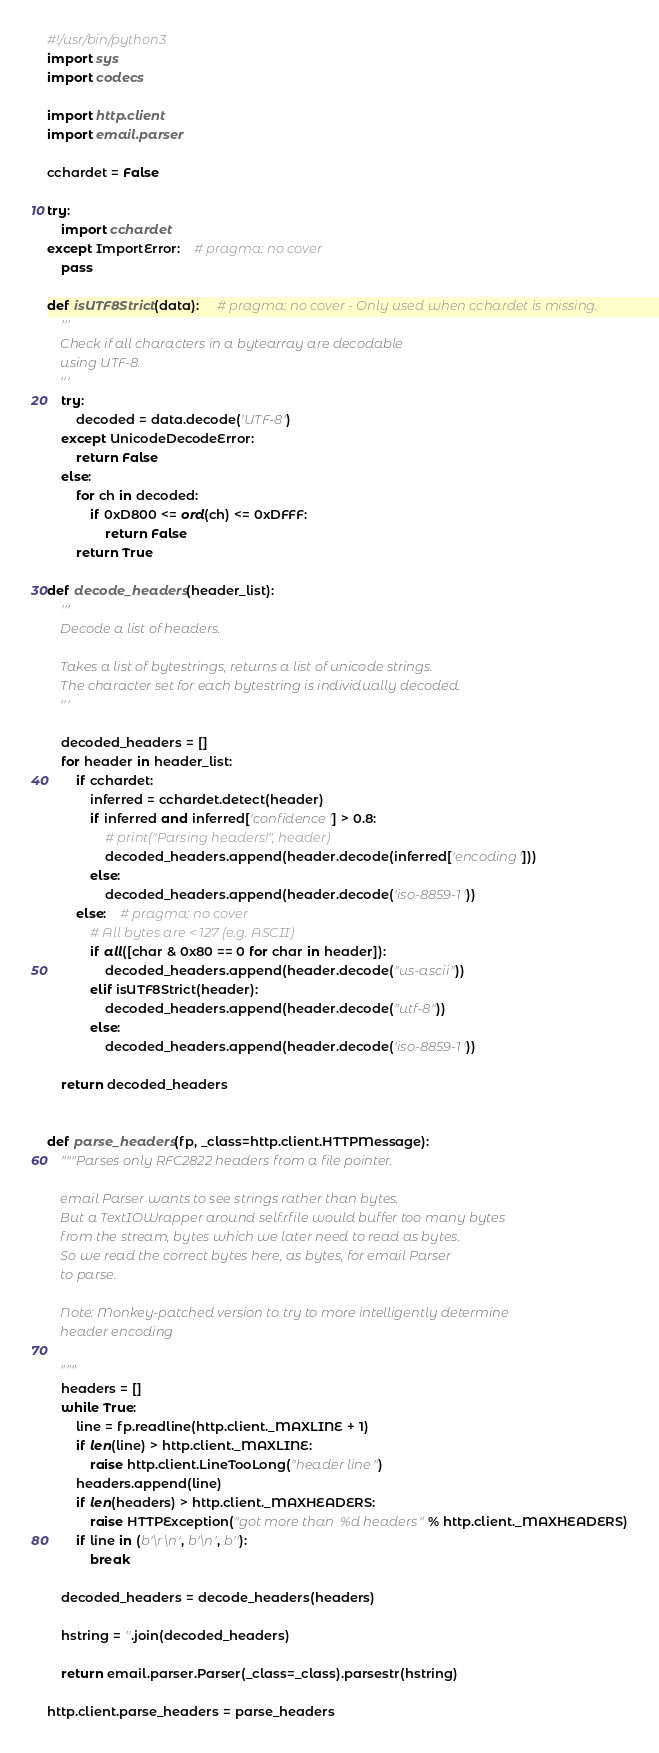Convert code to text. <code><loc_0><loc_0><loc_500><loc_500><_Python_>#!/usr/bin/python3
import sys
import codecs

import http.client
import email.parser

cchardet = False

try:
	import cchardet
except ImportError:    # pragma: no cover
	pass

def isUTF8Strict(data):     # pragma: no cover - Only used when cchardet is missing.
	'''
	Check if all characters in a bytearray are decodable
	using UTF-8.
	'''
	try:
		decoded = data.decode('UTF-8')
	except UnicodeDecodeError:
		return False
	else:
		for ch in decoded:
			if 0xD800 <= ord(ch) <= 0xDFFF:
				return False
		return True

def decode_headers(header_list):
	'''
	Decode a list of headers.

	Takes a list of bytestrings, returns a list of unicode strings.
	The character set for each bytestring is individually decoded.
	'''

	decoded_headers = []
	for header in header_list:
		if cchardet:
			inferred = cchardet.detect(header)
			if inferred and inferred['confidence'] > 0.8:
				# print("Parsing headers!", header)
				decoded_headers.append(header.decode(inferred['encoding']))
			else:
				decoded_headers.append(header.decode('iso-8859-1'))
		else:    # pragma: no cover
			# All bytes are < 127 (e.g. ASCII)
			if all([char & 0x80 == 0 for char in header]):
				decoded_headers.append(header.decode("us-ascii"))
			elif isUTF8Strict(header):
				decoded_headers.append(header.decode("utf-8"))
			else:
				decoded_headers.append(header.decode('iso-8859-1'))

	return decoded_headers


def parse_headers(fp, _class=http.client.HTTPMessage):
	"""Parses only RFC2822 headers from a file pointer.

	email Parser wants to see strings rather than bytes.
	But a TextIOWrapper around self.rfile would buffer too many bytes
	from the stream, bytes which we later need to read as bytes.
	So we read the correct bytes here, as bytes, for email Parser
	to parse.

	Note: Monkey-patched version to try to more intelligently determine
	header encoding

	"""
	headers = []
	while True:
		line = fp.readline(http.client._MAXLINE + 1)
		if len(line) > http.client._MAXLINE:
			raise http.client.LineTooLong("header line")
		headers.append(line)
		if len(headers) > http.client._MAXHEADERS:
			raise HTTPException("got more than %d headers" % http.client._MAXHEADERS)
		if line in (b'\r\n', b'\n', b''):
			break

	decoded_headers = decode_headers(headers)

	hstring = ''.join(decoded_headers)

	return email.parser.Parser(_class=_class).parsestr(hstring)

http.client.parse_headers = parse_headers
</code> 